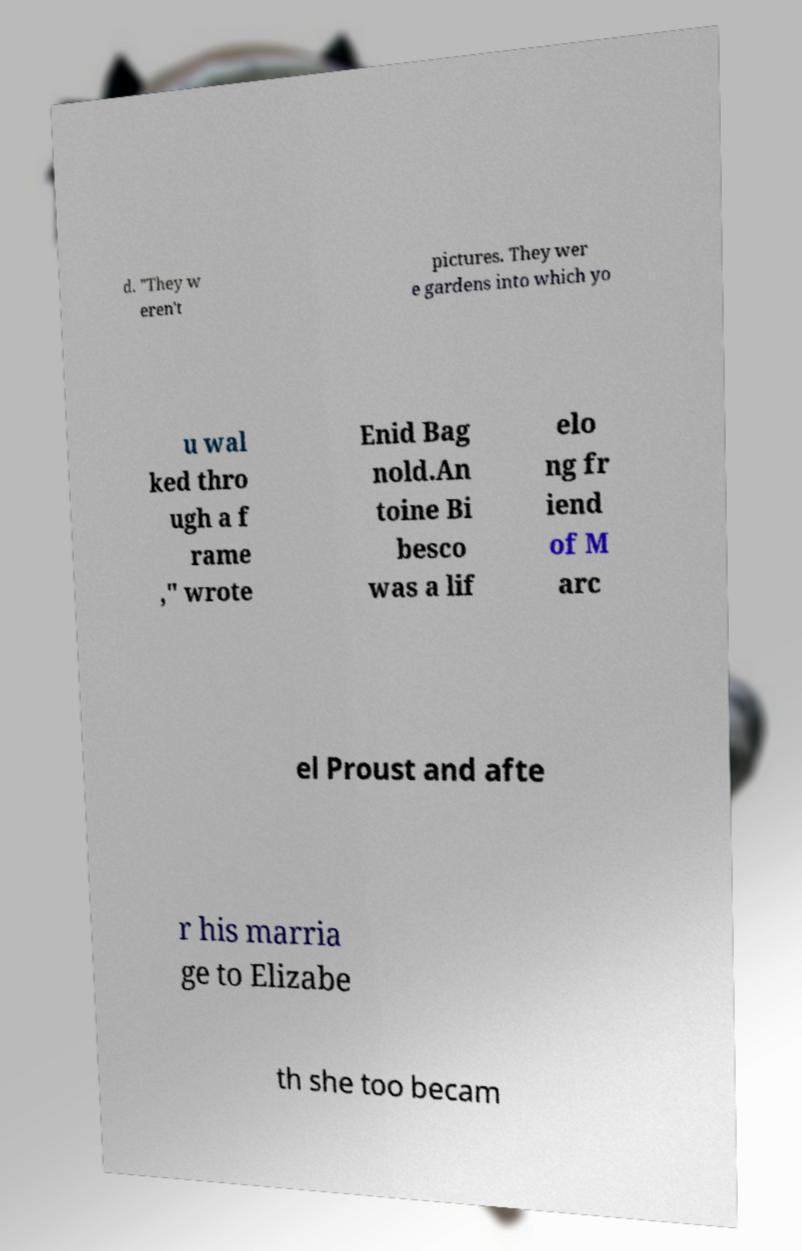Please read and relay the text visible in this image. What does it say? d. "They w eren't pictures. They wer e gardens into which yo u wal ked thro ugh a f rame ," wrote Enid Bag nold.An toine Bi besco was a lif elo ng fr iend of M arc el Proust and afte r his marria ge to Elizabe th she too becam 